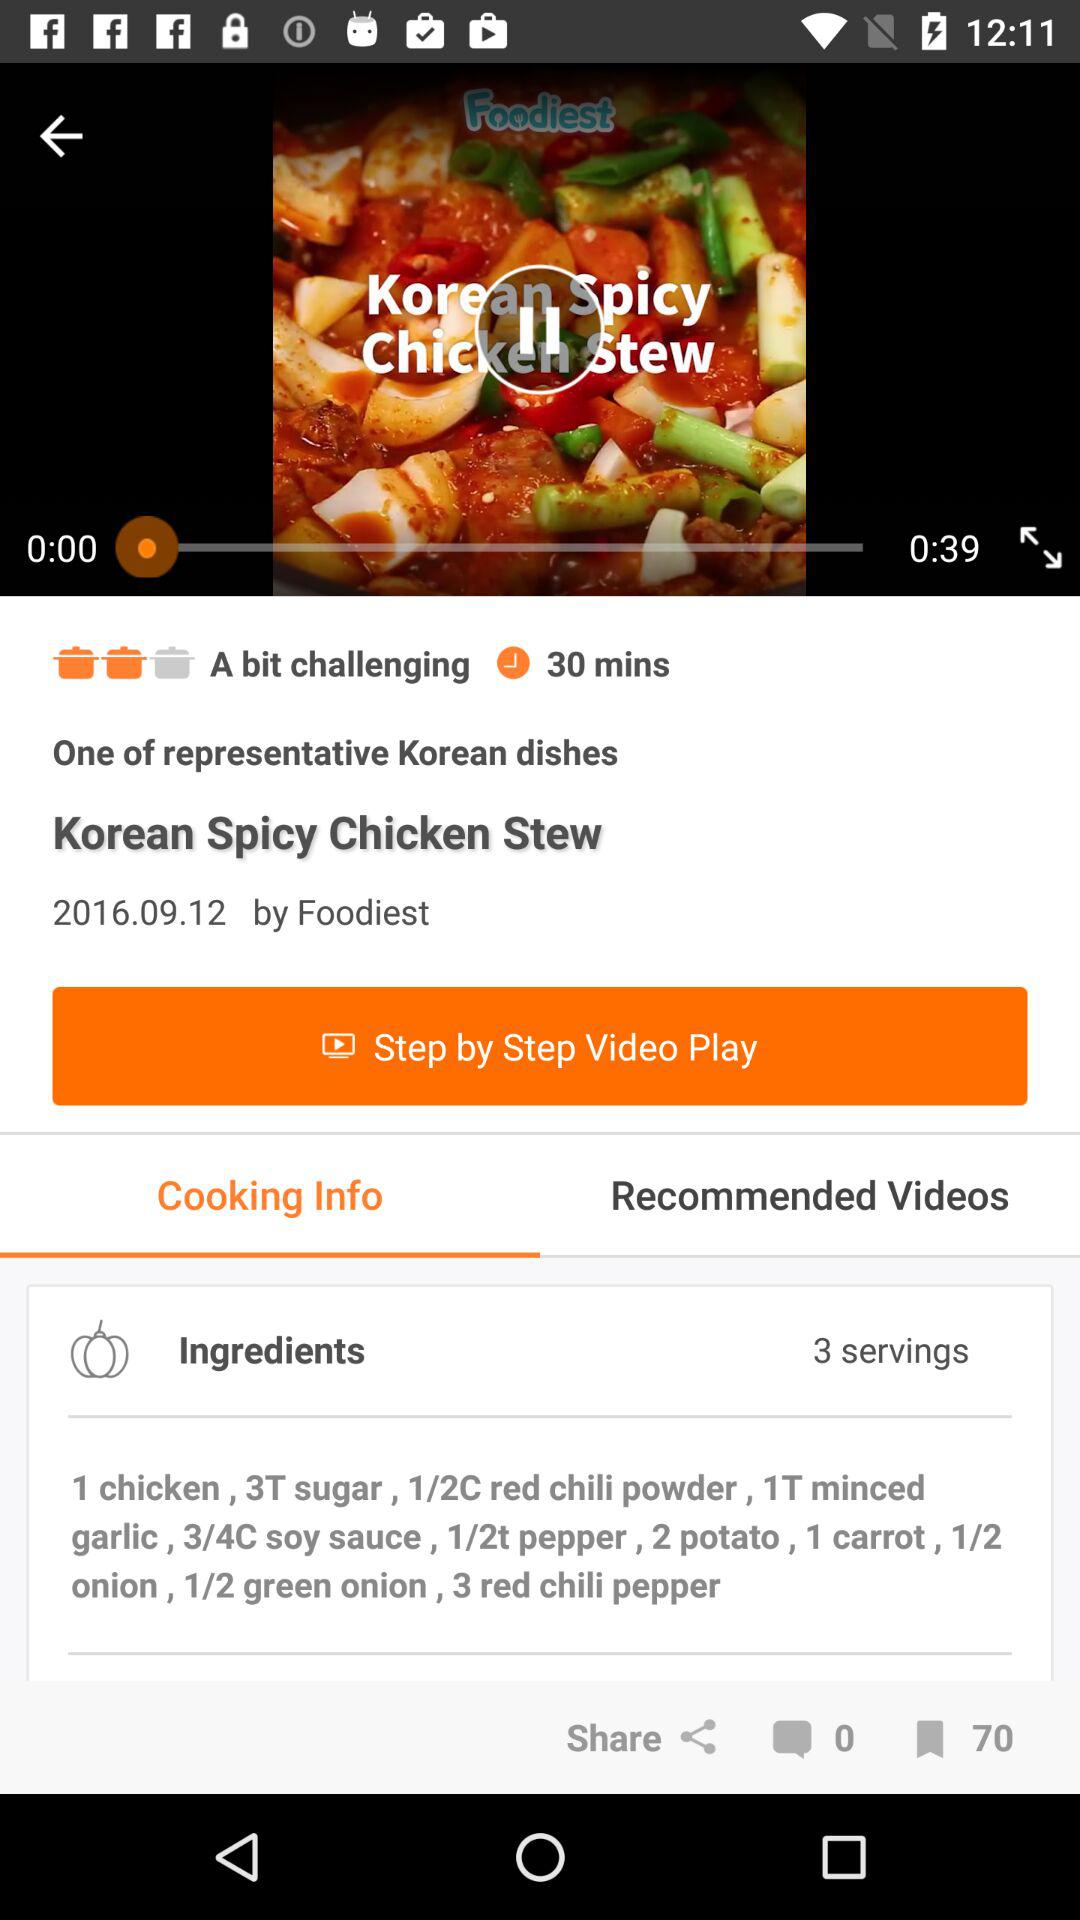How many servings is this recipe for?
Answer the question using a single word or phrase. 3 